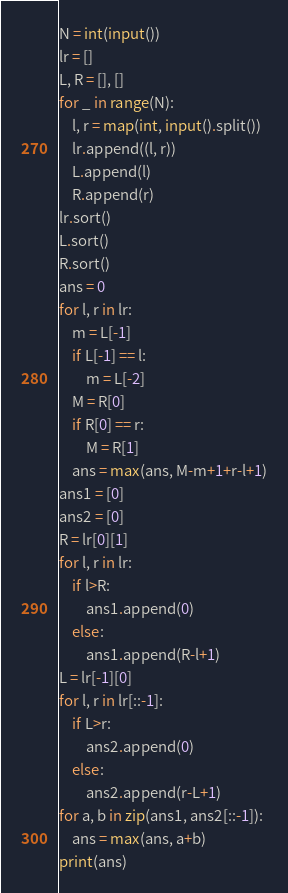<code> <loc_0><loc_0><loc_500><loc_500><_Python_>N = int(input())
lr = []
L, R = [], []
for _ in range(N):
    l, r = map(int, input().split())
    lr.append((l, r))
    L.append(l)
    R.append(r)
lr.sort()
L.sort()
R.sort()
ans = 0
for l, r in lr:  
    m = L[-1]
    if L[-1] == l:
        m = L[-2]
    M = R[0]
    if R[0] == r:
        M = R[1]
    ans = max(ans, M-m+1+r-l+1)
ans1 = [0]
ans2 = [0]
R = lr[0][1]
for l, r in lr:
    if l>R:
        ans1.append(0)
    else:
        ans1.append(R-l+1)
L = lr[-1][0]
for l, r in lr[::-1]:
    if L>r:
        ans2.append(0)
    else:
        ans2.append(r-L+1)
for a, b in zip(ans1, ans2[::-1]):
    ans = max(ans, a+b)
print(ans)</code> 